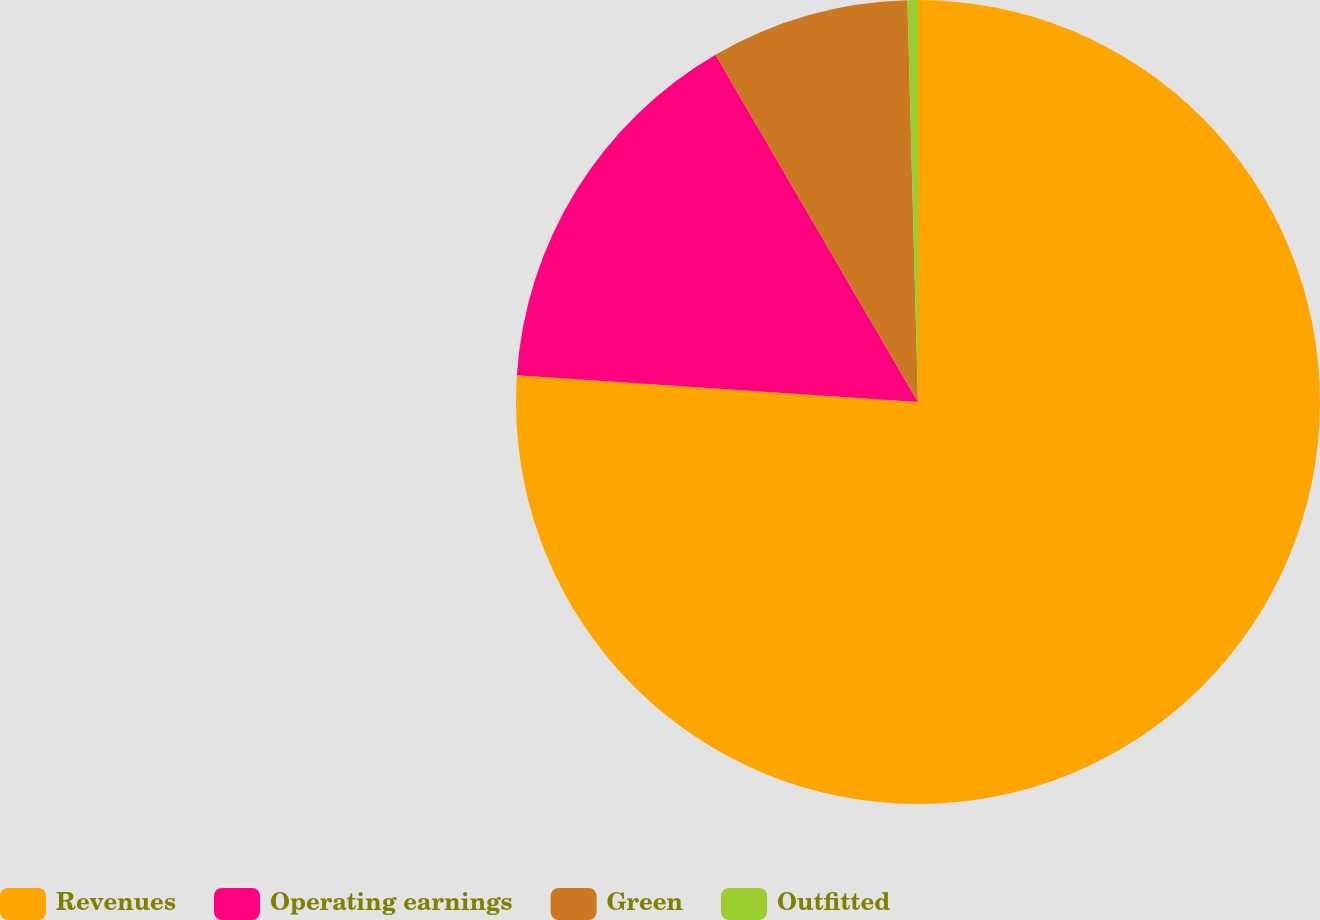Convert chart to OTSL. <chart><loc_0><loc_0><loc_500><loc_500><pie_chart><fcel>Revenues<fcel>Operating earnings<fcel>Green<fcel>Outfitted<nl><fcel>76.06%<fcel>15.54%<fcel>7.98%<fcel>0.42%<nl></chart> 